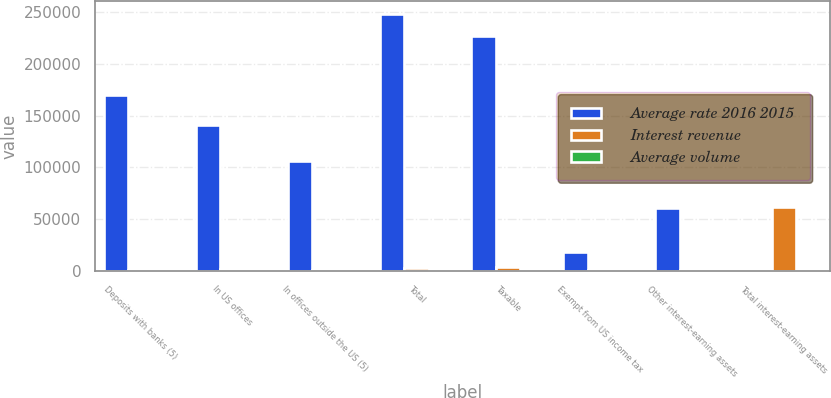Convert chart. <chart><loc_0><loc_0><loc_500><loc_500><stacked_bar_chart><ecel><fcel>Deposits with banks (5)<fcel>In US offices<fcel>In offices outside the US (5)<fcel>Total<fcel>Taxable<fcel>Exempt from US income tax<fcel>Other interest-earning assets<fcel>Total interest-earning assets<nl><fcel>Average rate 2016 2015<fcel>169385<fcel>141308<fcel>106605<fcel>247913<fcel>226227<fcel>18152<fcel>60628<fcel>1635<nl><fcel>Interest revenue<fcel>1635<fcel>1922<fcel>1326<fcel>3248<fcel>4450<fcel>775<fcel>1163<fcel>61700<nl><fcel>Average volume<fcel>0.97<fcel>1.36<fcel>1.24<fcel>1.31<fcel>1.97<fcel>4.27<fcel>1.92<fcel>3.69<nl></chart> 